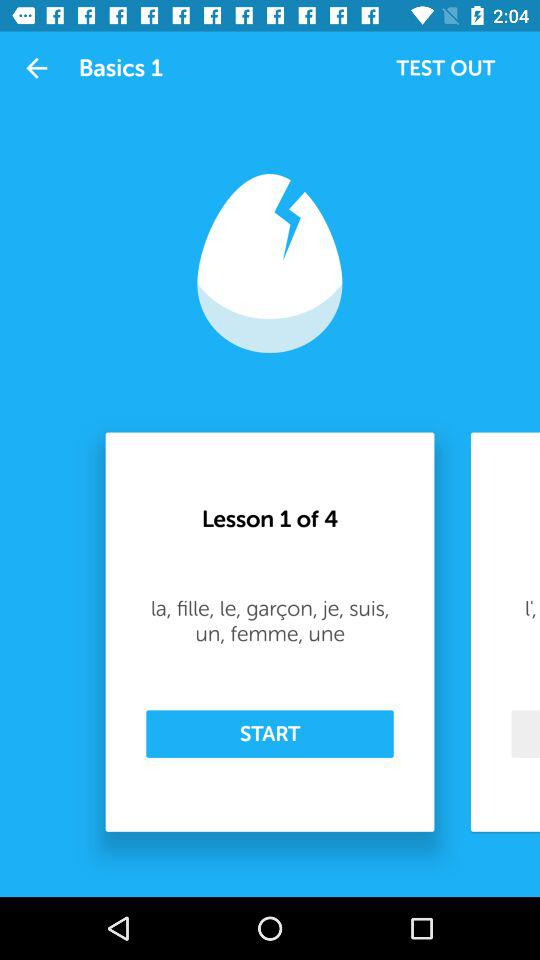How many lessons in total are there? There are 4 lessons in total. 